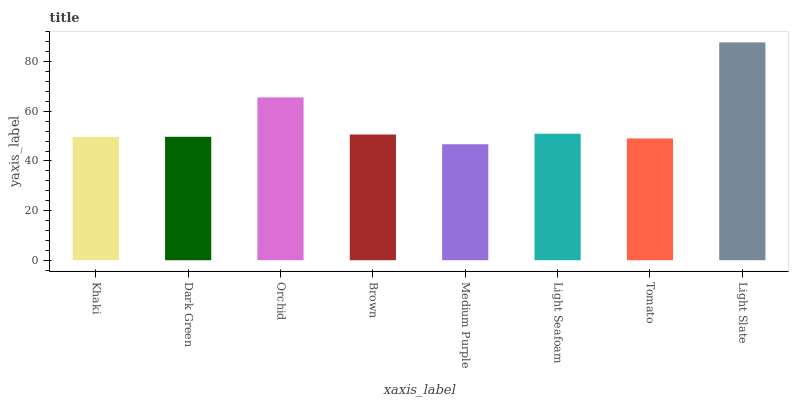Is Medium Purple the minimum?
Answer yes or no. Yes. Is Light Slate the maximum?
Answer yes or no. Yes. Is Dark Green the minimum?
Answer yes or no. No. Is Dark Green the maximum?
Answer yes or no. No. Is Dark Green greater than Khaki?
Answer yes or no. Yes. Is Khaki less than Dark Green?
Answer yes or no. Yes. Is Khaki greater than Dark Green?
Answer yes or no. No. Is Dark Green less than Khaki?
Answer yes or no. No. Is Brown the high median?
Answer yes or no. Yes. Is Dark Green the low median?
Answer yes or no. Yes. Is Khaki the high median?
Answer yes or no. No. Is Brown the low median?
Answer yes or no. No. 